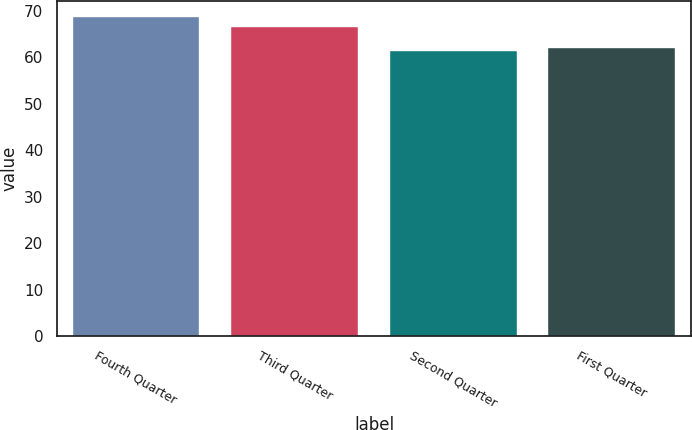Convert chart to OTSL. <chart><loc_0><loc_0><loc_500><loc_500><bar_chart><fcel>Fourth Quarter<fcel>Third Quarter<fcel>Second Quarter<fcel>First Quarter<nl><fcel>68.74<fcel>66.53<fcel>61.29<fcel>62.03<nl></chart> 